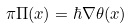<formula> <loc_0><loc_0><loc_500><loc_500>\pi \Pi ( x ) = \hbar { \nabla } \theta ( x )</formula> 